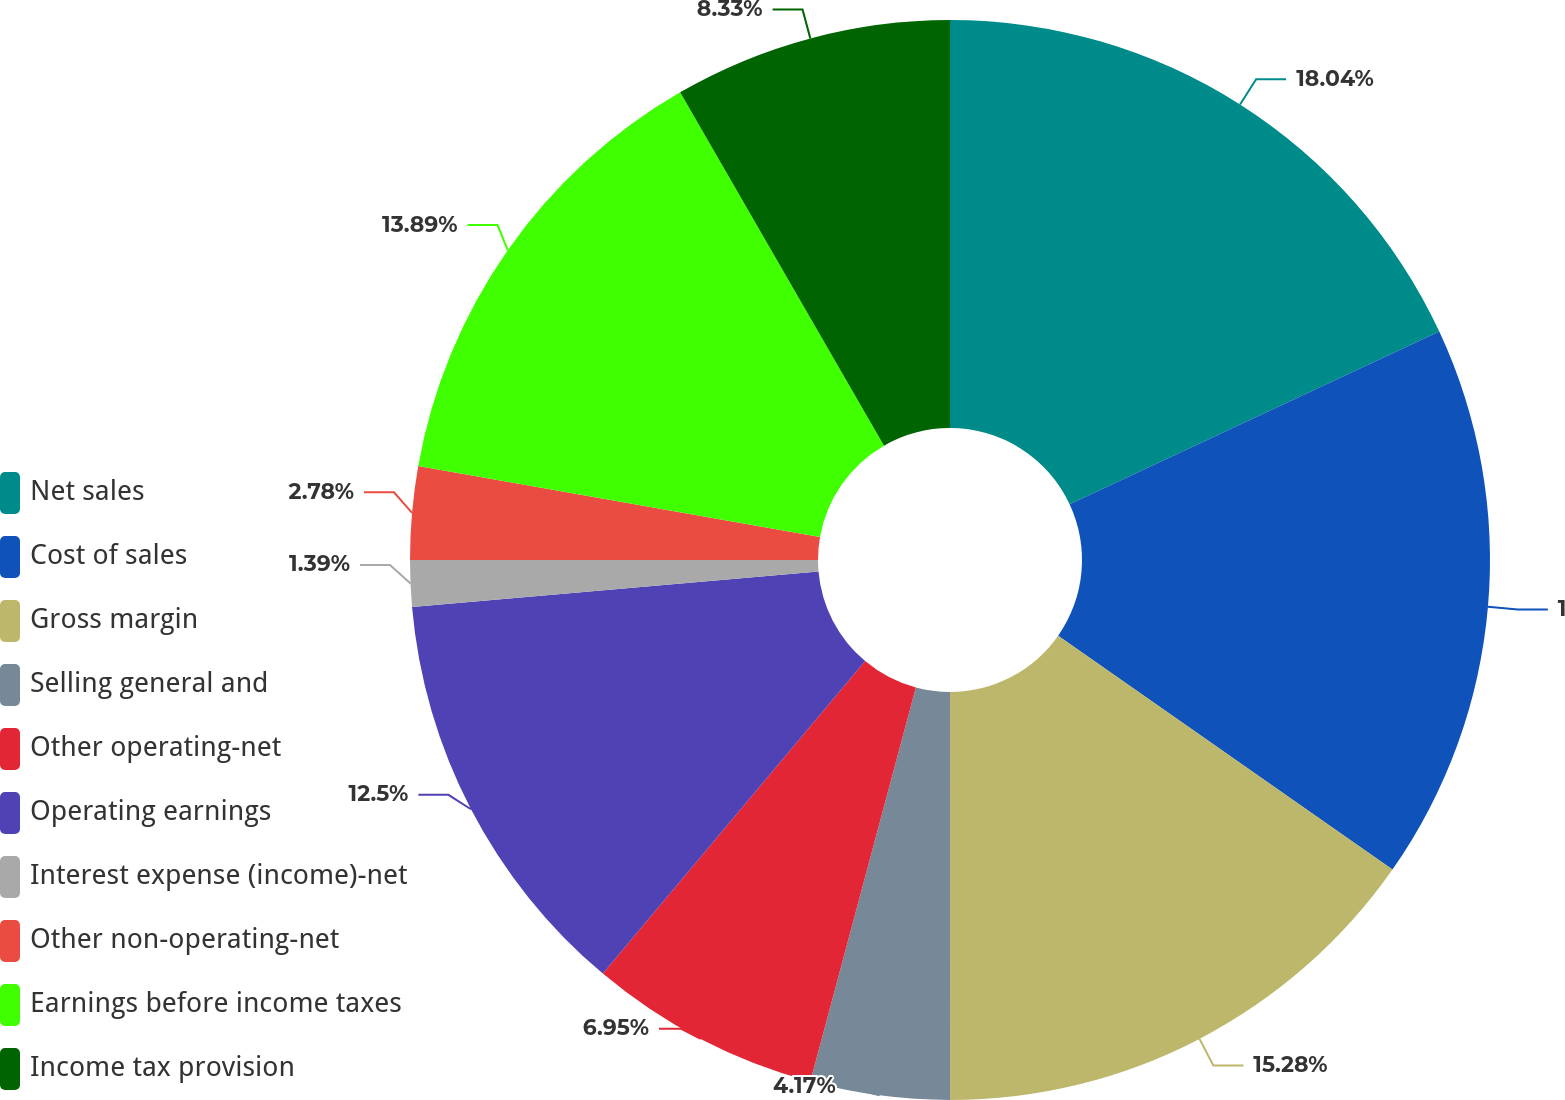Convert chart. <chart><loc_0><loc_0><loc_500><loc_500><pie_chart><fcel>Net sales<fcel>Cost of sales<fcel>Gross margin<fcel>Selling general and<fcel>Other operating-net<fcel>Operating earnings<fcel>Interest expense (income)-net<fcel>Other non-operating-net<fcel>Earnings before income taxes<fcel>Income tax provision<nl><fcel>18.05%<fcel>16.67%<fcel>15.28%<fcel>4.17%<fcel>6.95%<fcel>12.5%<fcel>1.39%<fcel>2.78%<fcel>13.89%<fcel>8.33%<nl></chart> 